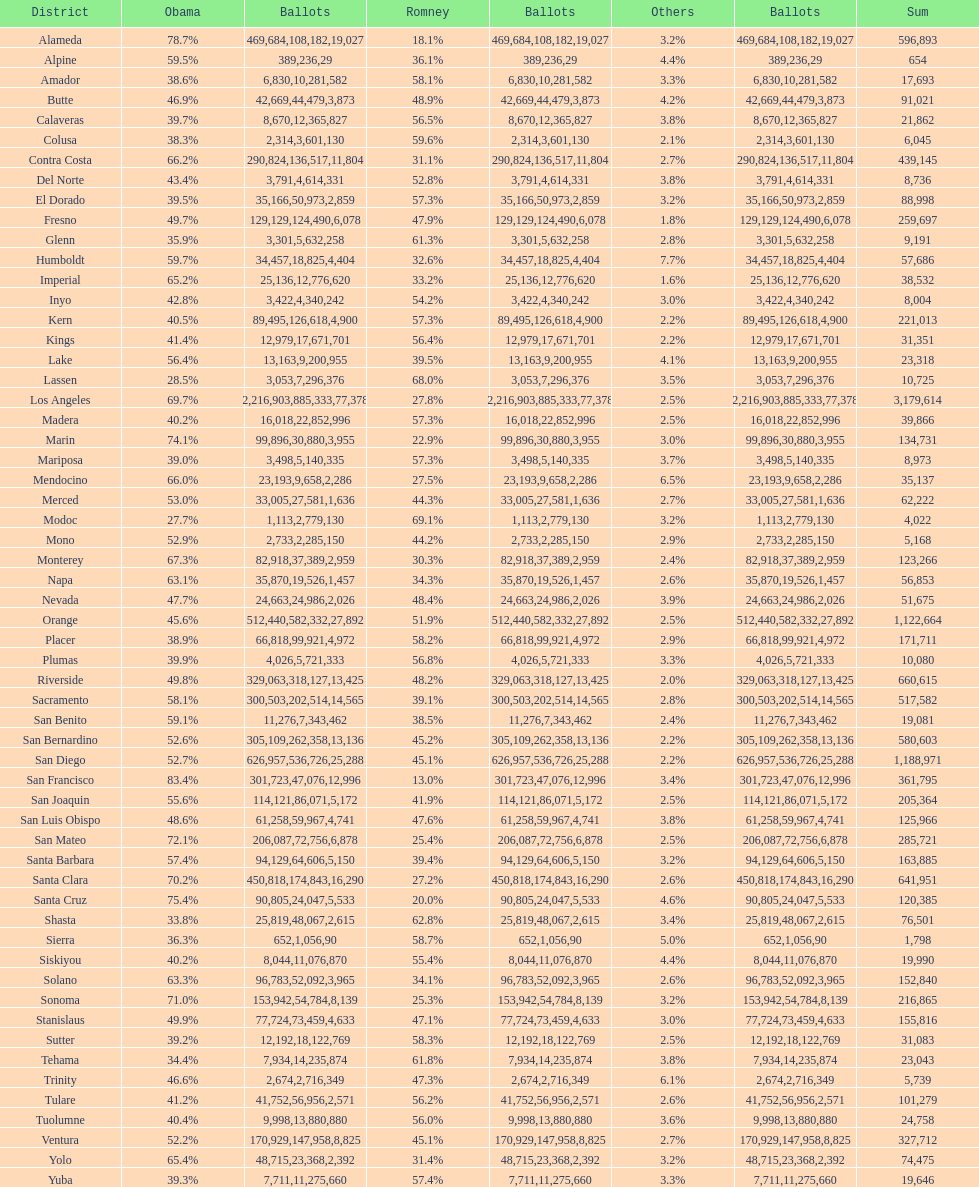What is the complete tally of votes for amador? 17693. 